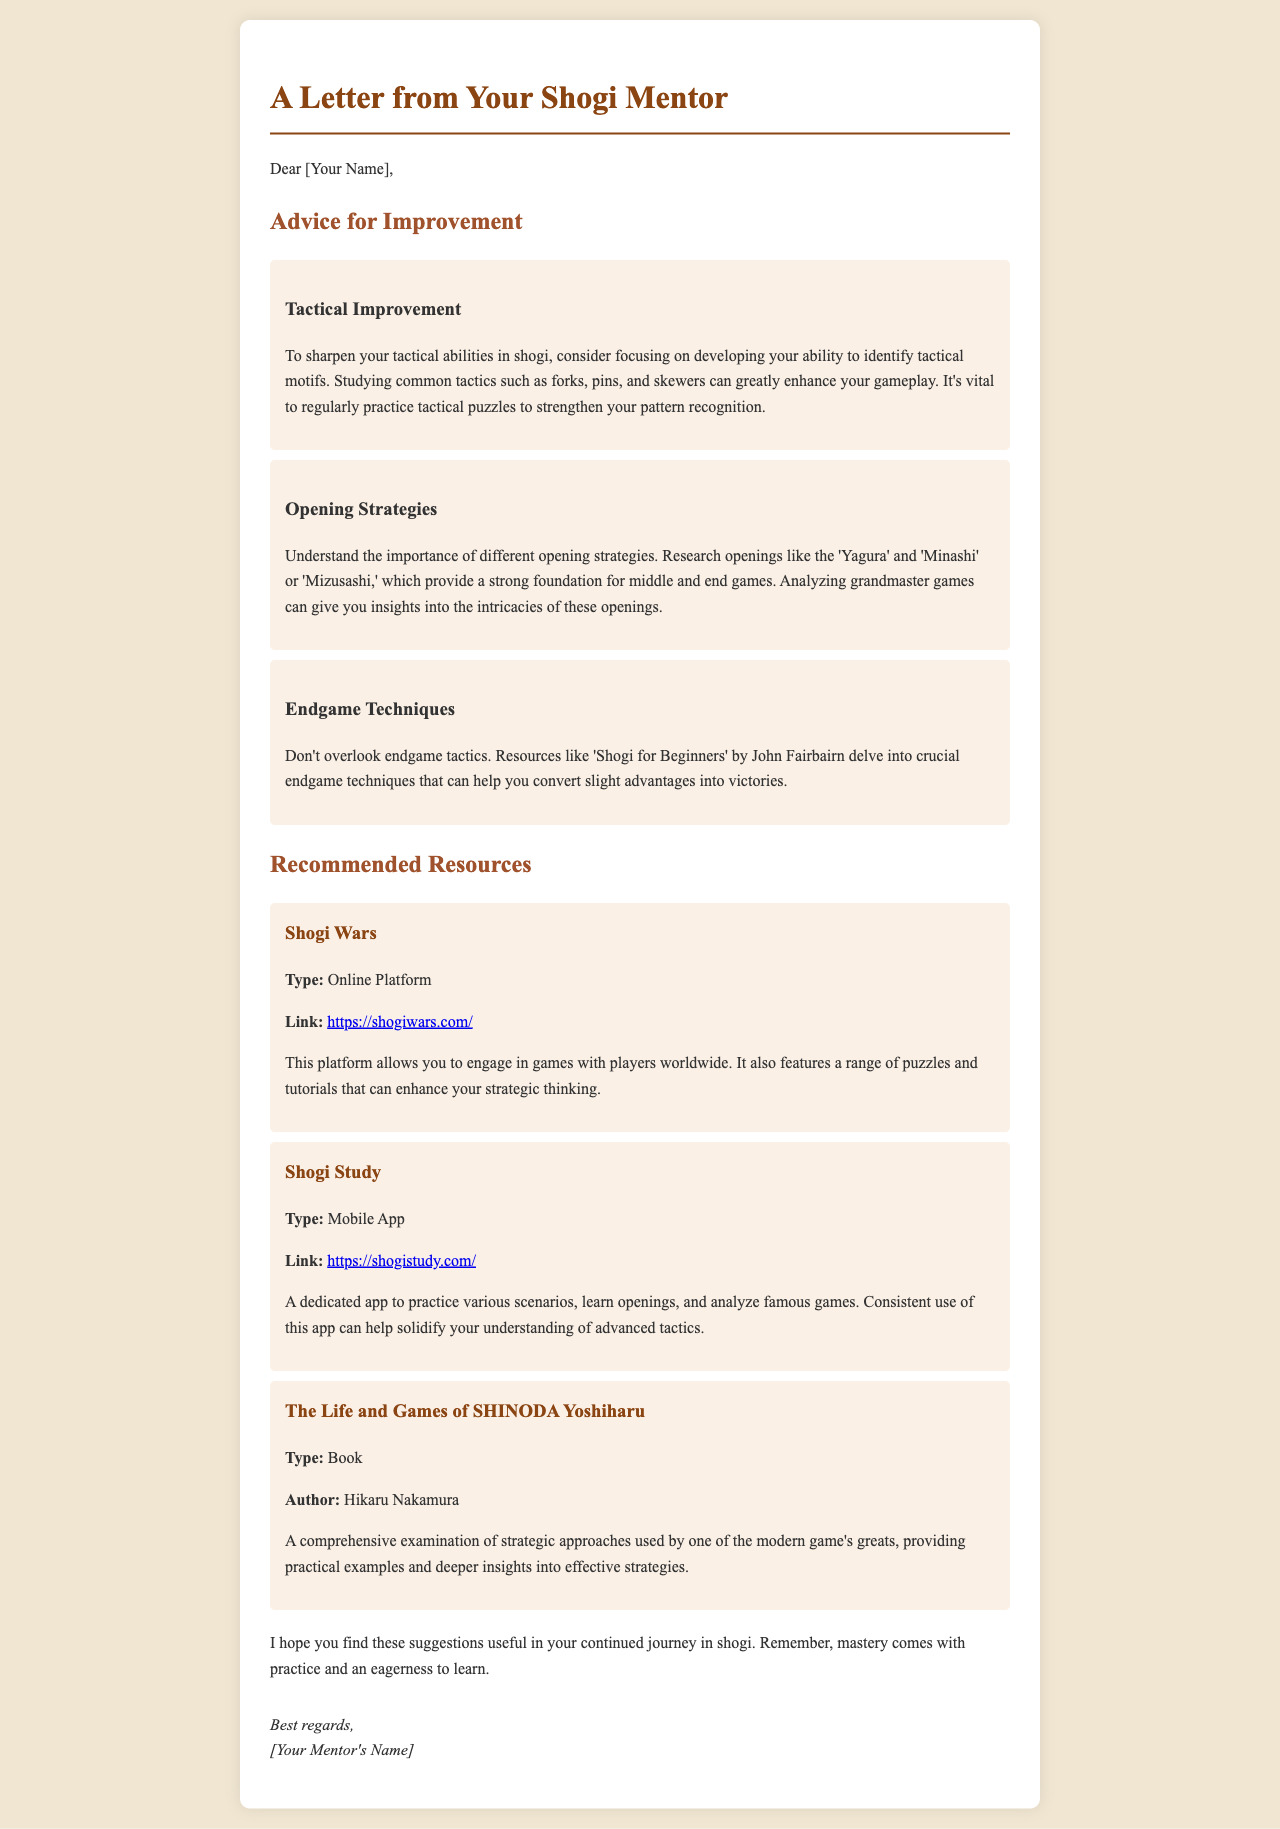What is the title of the letter? The title of the letter is prominently displayed at the top of the document.
Answer: A Letter from Your Shogi Mentor Who is the author of the recommended book? The author of the book "The Life and Games of SHINODA Yoshiharu" is mentioned in the resources section.
Answer: Hikaru Nakamura What online platform is recommended for engaging with players worldwide? The letter includes details about different resources, specifically naming one online platform.
Answer: Shogi Wars What is one tactical motif mentioned for improving shogi skills? The letter lists various tactical motifs and highlights one for the reader's focus.
Answer: forks Which resource focuses on practicing various scenarios and openings? The resources section outlines several recommended tools for shogi practice, identifying one specifically for scenarios and openings.
Answer: Shogi Study What is emphasized as vital for tactical improvement in the letter? The mentor advises on a specific practice method essential for enhancing tactical skills.
Answer: practicing tactical puzzles What is the main advice regarding endgame techniques? The mentor mentions a specific resource that helps in understanding endgame tactics in the letter.
Answer: Shogi for Beginners What is the mentor's closing remark about mastery? The letter concludes with an encouraging statement about the relationship between practice and mastery in shogi.
Answer: mastery comes with practice and an eagerness to learn 